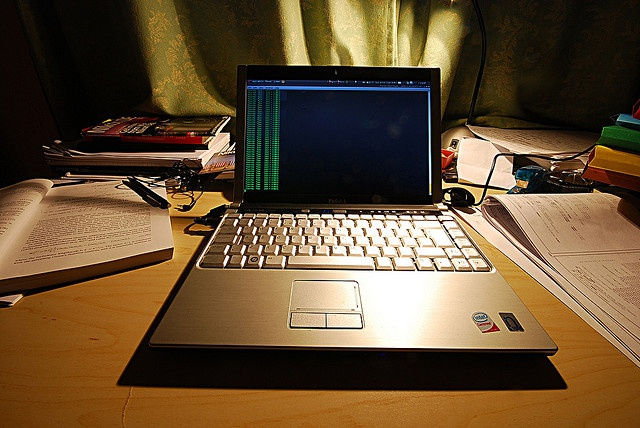Describe the objects in this image and their specific colors. I can see laptop in black, ivory, tan, and maroon tones, book in black, tan, and gray tones, book in black, maroon, and tan tones, book in black, maroon, and brown tones, and book in black, khaki, beige, and maroon tones in this image. 